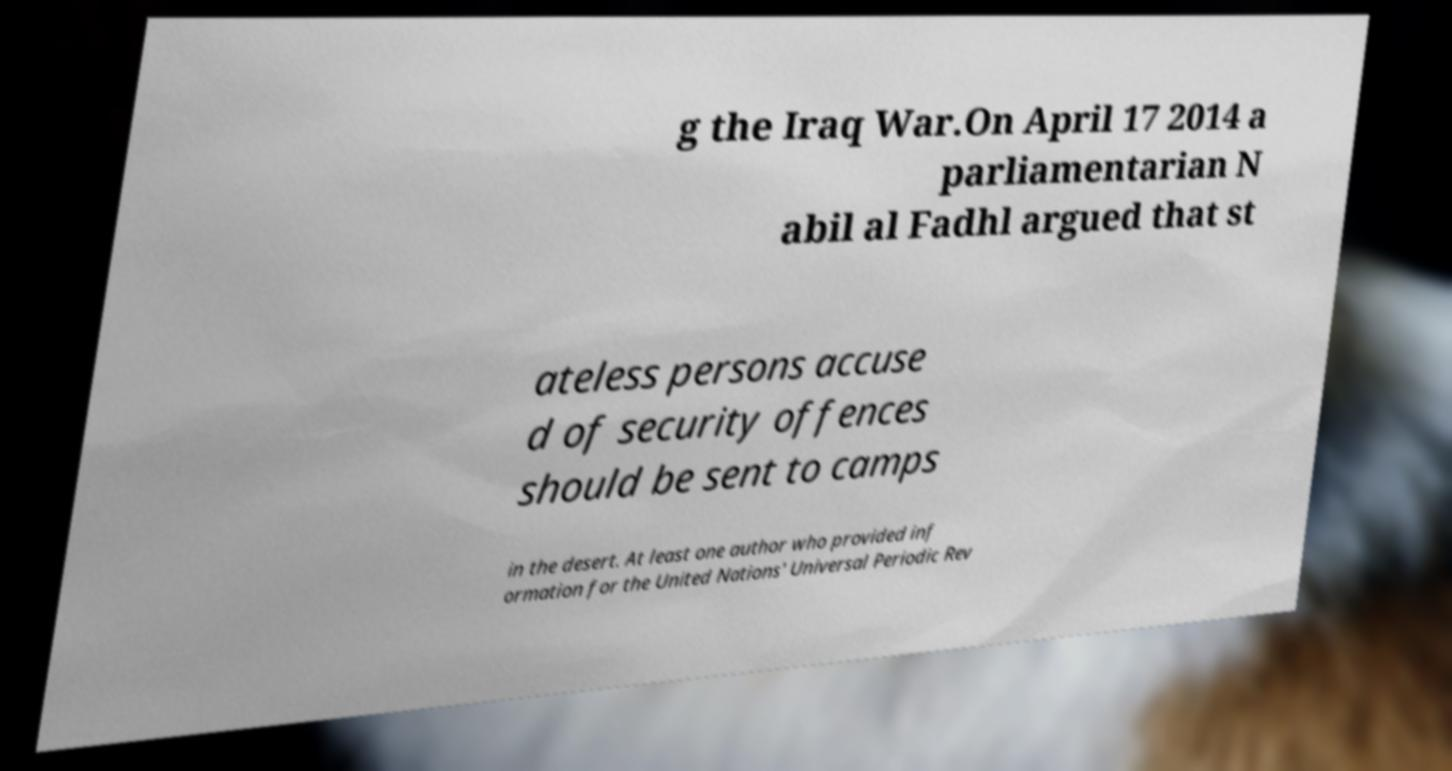Please read and relay the text visible in this image. What does it say? g the Iraq War.On April 17 2014 a parliamentarian N abil al Fadhl argued that st ateless persons accuse d of security offences should be sent to camps in the desert. At least one author who provided inf ormation for the United Nations' Universal Periodic Rev 